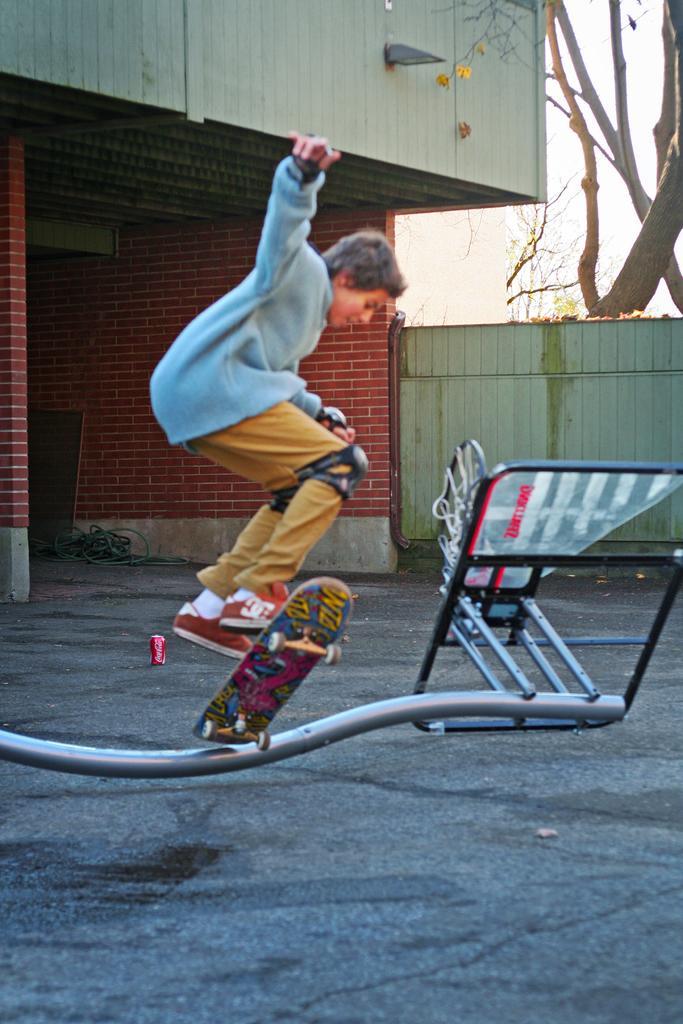Could you give a brief overview of what you see in this image? In this picture we can see a boy is jumping with the skateboard and on the path there is an item. Behind the boy there is a wall, tree and a sky. 